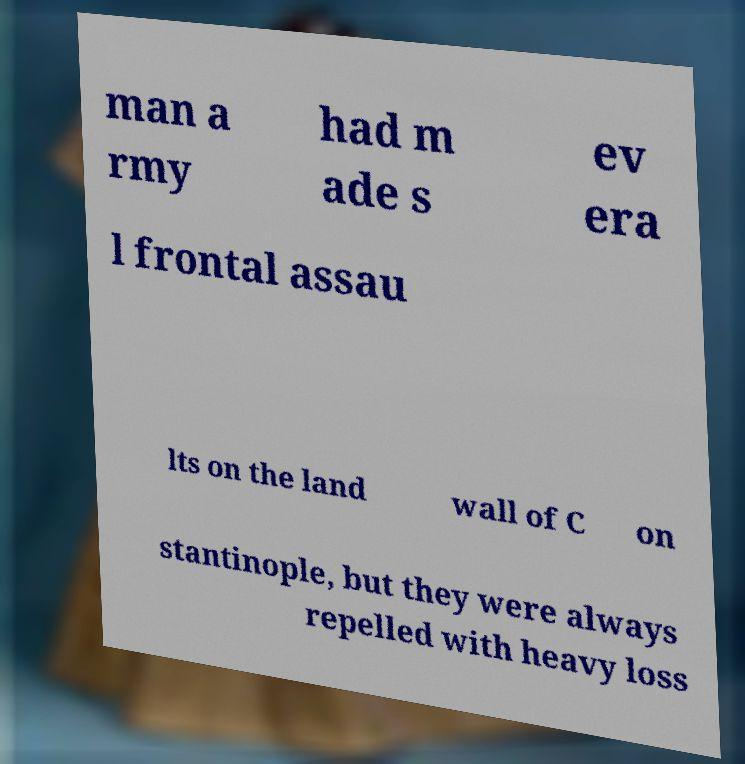Can you accurately transcribe the text from the provided image for me? man a rmy had m ade s ev era l frontal assau lts on the land wall of C on stantinople, but they were always repelled with heavy loss 